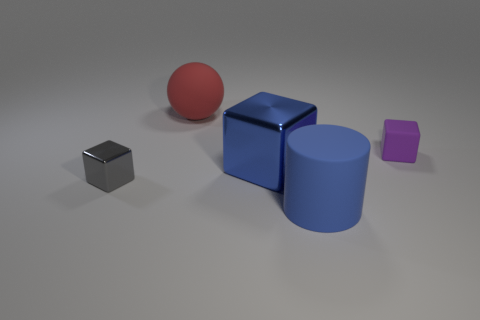Add 4 large purple cylinders. How many objects exist? 9 Subtract all spheres. How many objects are left? 4 Subtract 0 yellow cylinders. How many objects are left? 5 Subtract all purple objects. Subtract all purple objects. How many objects are left? 3 Add 4 large blue shiny objects. How many large blue shiny objects are left? 5 Add 4 large matte things. How many large matte things exist? 6 